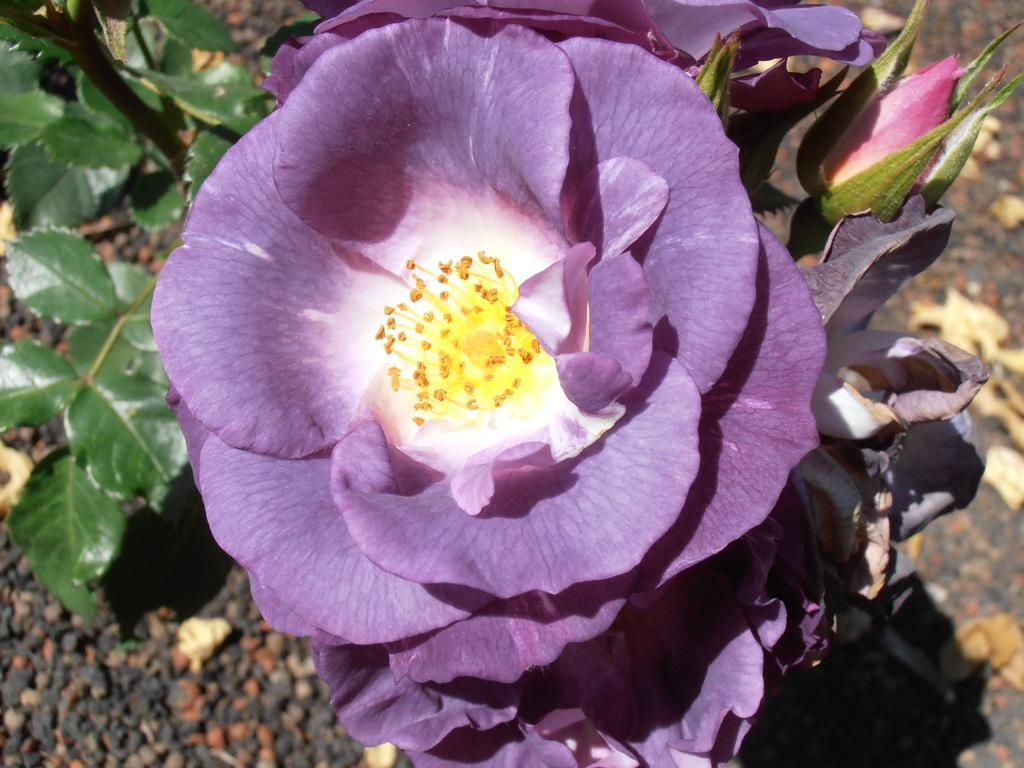What type of flower is in the image? There is a purple flower in the image. Where is the flower located? The flower is on a plant. What is the plant situated on? The plant is on the land. What type of spy equipment can be seen in the image? There is no spy equipment present in the image; it features a purple flower on a plant. How many toads are visible in the image? There are no toads present in the image. 